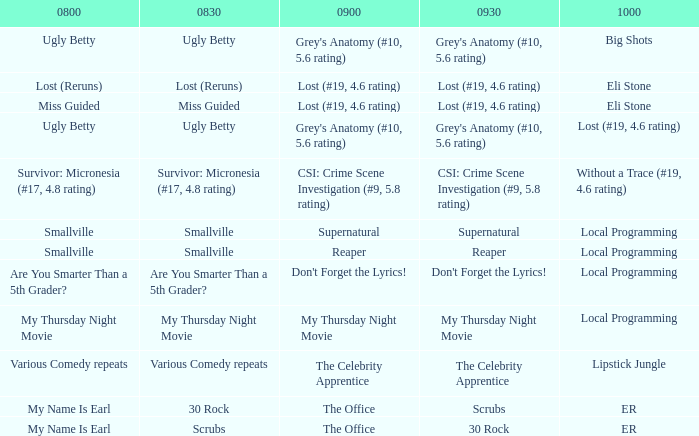What is at 9:00 when at 10:00 it is local programming and at 9:30 it is my thursday night movie? My Thursday Night Movie. Can you give me this table as a dict? {'header': ['0800', '0830', '0900', '0930', '1000'], 'rows': [['Ugly Betty', 'Ugly Betty', "Grey's Anatomy (#10, 5.6 rating)", "Grey's Anatomy (#10, 5.6 rating)", 'Big Shots'], ['Lost (Reruns)', 'Lost (Reruns)', 'Lost (#19, 4.6 rating)', 'Lost (#19, 4.6 rating)', 'Eli Stone'], ['Miss Guided', 'Miss Guided', 'Lost (#19, 4.6 rating)', 'Lost (#19, 4.6 rating)', 'Eli Stone'], ['Ugly Betty', 'Ugly Betty', "Grey's Anatomy (#10, 5.6 rating)", "Grey's Anatomy (#10, 5.6 rating)", 'Lost (#19, 4.6 rating)'], ['Survivor: Micronesia (#17, 4.8 rating)', 'Survivor: Micronesia (#17, 4.8 rating)', 'CSI: Crime Scene Investigation (#9, 5.8 rating)', 'CSI: Crime Scene Investigation (#9, 5.8 rating)', 'Without a Trace (#19, 4.6 rating)'], ['Smallville', 'Smallville', 'Supernatural', 'Supernatural', 'Local Programming'], ['Smallville', 'Smallville', 'Reaper', 'Reaper', 'Local Programming'], ['Are You Smarter Than a 5th Grader?', 'Are You Smarter Than a 5th Grader?', "Don't Forget the Lyrics!", "Don't Forget the Lyrics!", 'Local Programming'], ['My Thursday Night Movie', 'My Thursday Night Movie', 'My Thursday Night Movie', 'My Thursday Night Movie', 'Local Programming'], ['Various Comedy repeats', 'Various Comedy repeats', 'The Celebrity Apprentice', 'The Celebrity Apprentice', 'Lipstick Jungle'], ['My Name Is Earl', '30 Rock', 'The Office', 'Scrubs', 'ER'], ['My Name Is Earl', 'Scrubs', 'The Office', '30 Rock', 'ER']]} 